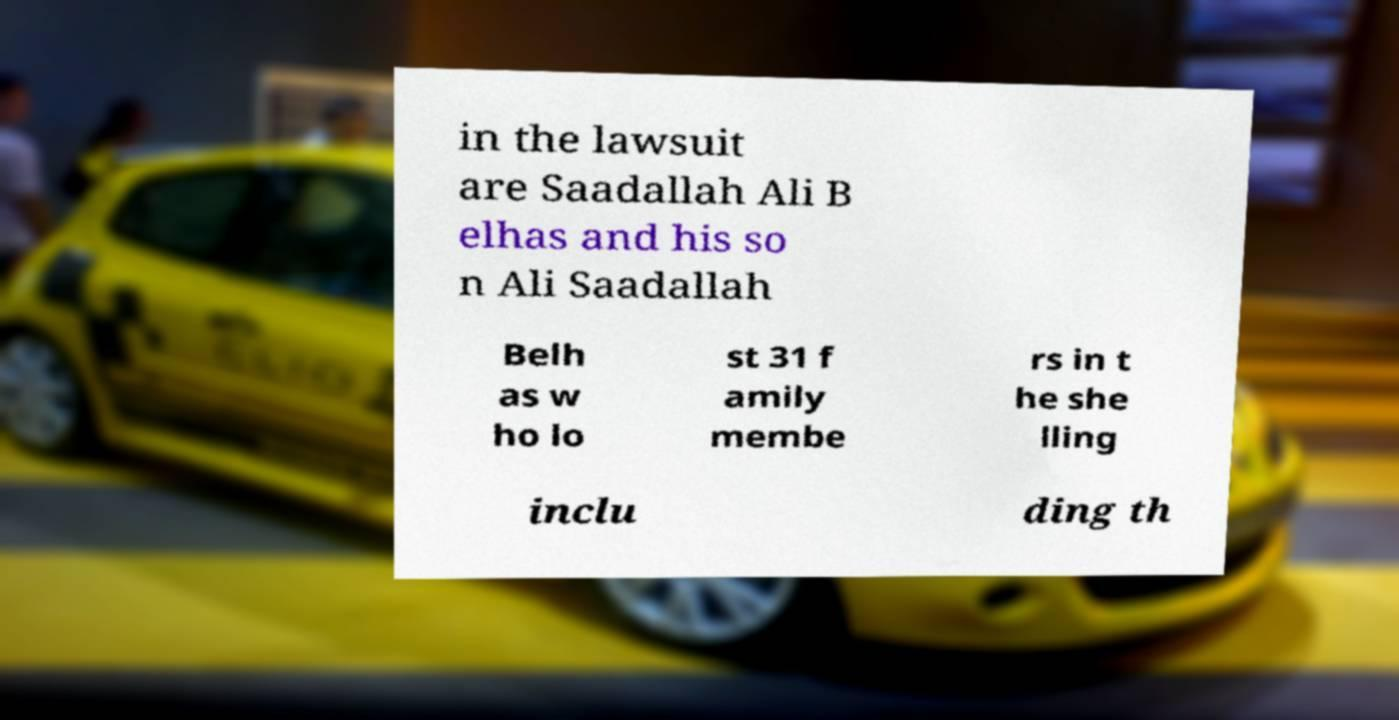Can you read and provide the text displayed in the image?This photo seems to have some interesting text. Can you extract and type it out for me? in the lawsuit are Saadallah Ali B elhas and his so n Ali Saadallah Belh as w ho lo st 31 f amily membe rs in t he she lling inclu ding th 